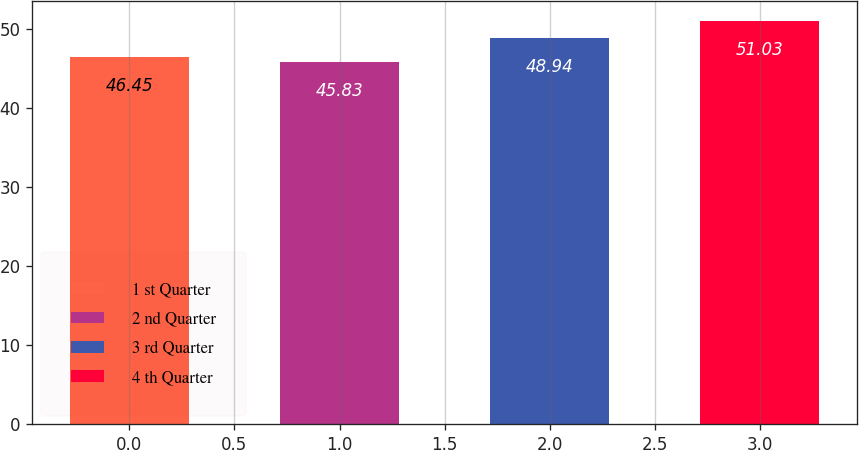<chart> <loc_0><loc_0><loc_500><loc_500><bar_chart><fcel>1 st Quarter<fcel>2 nd Quarter<fcel>3 rd Quarter<fcel>4 th Quarter<nl><fcel>46.45<fcel>45.83<fcel>48.94<fcel>51.03<nl></chart> 